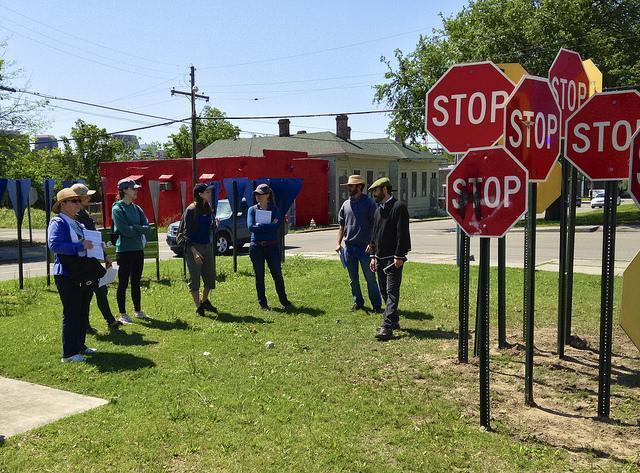How many stop signs are there?
Give a very brief answer. 5. How many people are in this scene?
Give a very brief answer. 7. How many people can you see?
Give a very brief answer. 6. How many stop signs can you see?
Give a very brief answer. 5. 